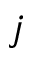<formula> <loc_0><loc_0><loc_500><loc_500>j</formula> 